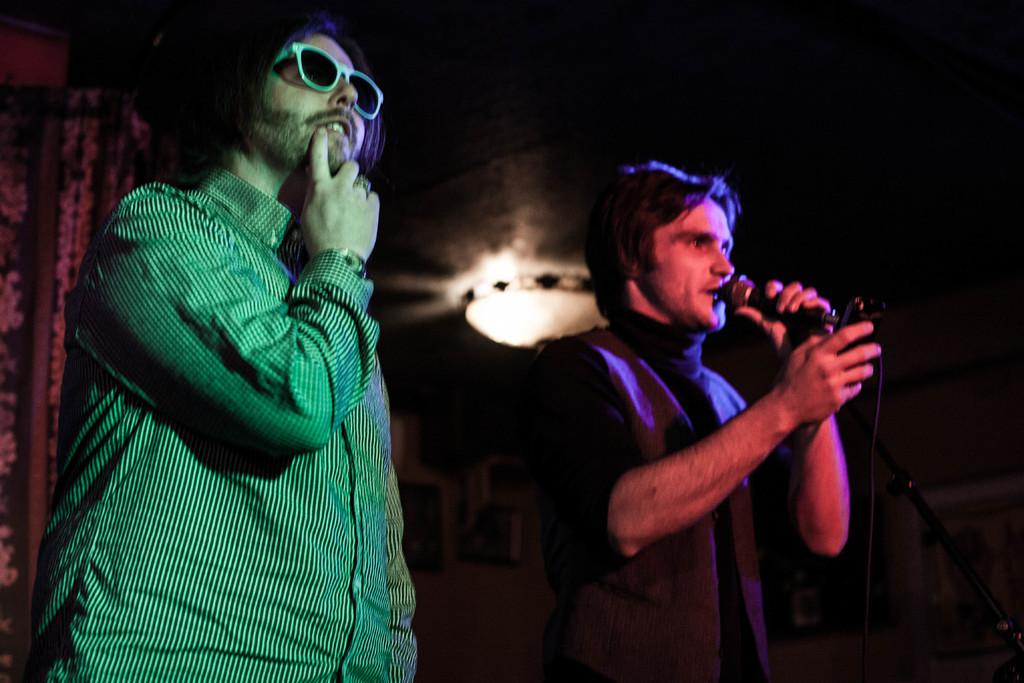How many people are present in the image? There are two men standing in the image. What is one of the men holding? One of the men is holding a microphone. What can be seen in the background of the image? There is a wall, a light, and a curtain in the background of the image. What type of loaf is being bitten by one of the men in the image? There is no loaf or any food item present in the image. Can you describe the coastline visible in the background of the image? There is no coastline visible in the image; it features a wall, a light, and a curtain in the background. 